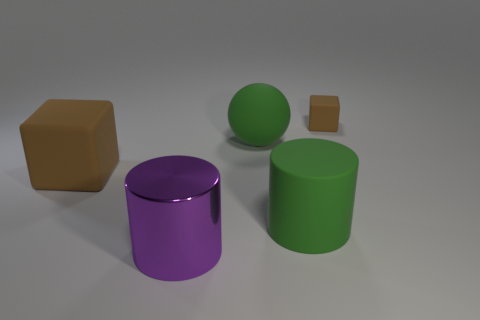Subtract all purple spheres. Subtract all purple blocks. How many spheres are left? 1 Add 4 tiny cubes. How many objects exist? 9 Subtract all blocks. How many objects are left? 3 Subtract 0 blue blocks. How many objects are left? 5 Subtract all big purple cylinders. Subtract all tiny brown matte blocks. How many objects are left? 3 Add 4 rubber balls. How many rubber balls are left? 5 Add 5 small brown rubber blocks. How many small brown rubber blocks exist? 6 